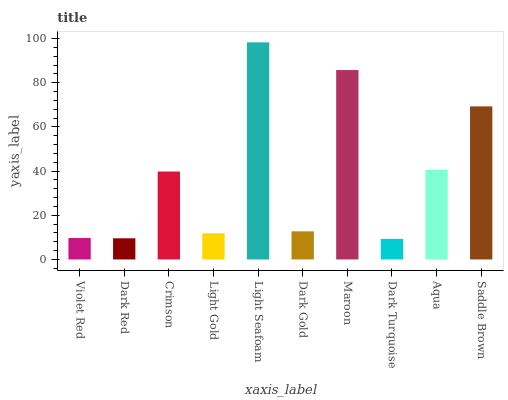Is Dark Turquoise the minimum?
Answer yes or no. Yes. Is Light Seafoam the maximum?
Answer yes or no. Yes. Is Dark Red the minimum?
Answer yes or no. No. Is Dark Red the maximum?
Answer yes or no. No. Is Violet Red greater than Dark Red?
Answer yes or no. Yes. Is Dark Red less than Violet Red?
Answer yes or no. Yes. Is Dark Red greater than Violet Red?
Answer yes or no. No. Is Violet Red less than Dark Red?
Answer yes or no. No. Is Crimson the high median?
Answer yes or no. Yes. Is Dark Gold the low median?
Answer yes or no. Yes. Is Violet Red the high median?
Answer yes or no. No. Is Aqua the low median?
Answer yes or no. No. 